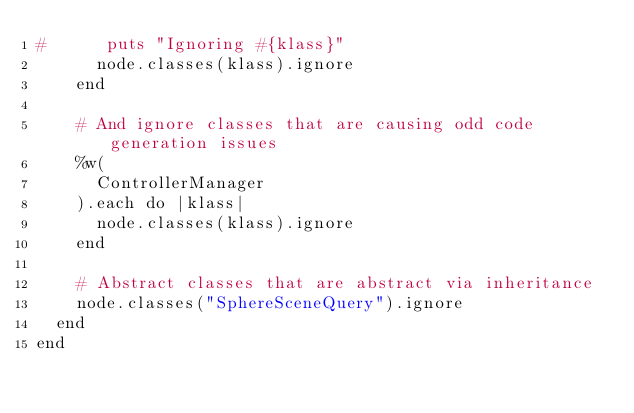<code> <loc_0><loc_0><loc_500><loc_500><_Ruby_>#      puts "Ignoring #{klass}"
      node.classes(klass).ignore
    end

    # And ignore classes that are causing odd code generation issues
    %w(
      ControllerManager
    ).each do |klass|
      node.classes(klass).ignore
    end

    # Abstract classes that are abstract via inheritance
    node.classes("SphereSceneQuery").ignore
  end
end
</code> 